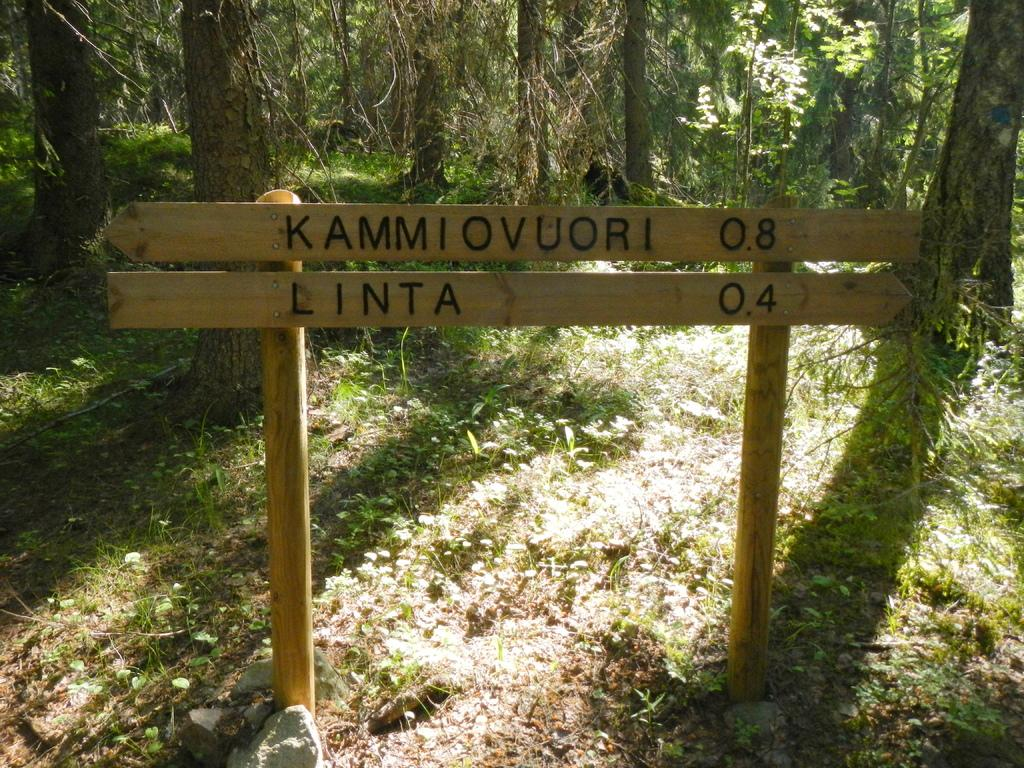What is the main object in the center of the image? There is a sign board in the center of the image. What can be seen in the background of the image? There are trees in the background of the image. What type of vegetation is present at the bottom of the image? There is dry grass at the bottom of the image. How many thumbs can be seen on the sign board in the image? There are no thumbs present on the sign board in the image. What type of grain is growing in the image? There is no grain visible in the image; it features a sign board, trees, and dry grass. 